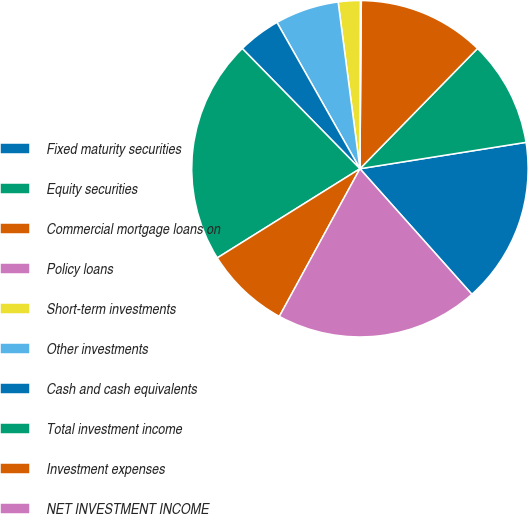Convert chart to OTSL. <chart><loc_0><loc_0><loc_500><loc_500><pie_chart><fcel>Fixed maturity securities<fcel>Equity securities<fcel>Commercial mortgage loans on<fcel>Policy loans<fcel>Short-term investments<fcel>Other investments<fcel>Cash and cash equivalents<fcel>Total investment income<fcel>Investment expenses<fcel>NET INVESTMENT INCOME<nl><fcel>15.92%<fcel>10.17%<fcel>12.19%<fcel>0.09%<fcel>2.11%<fcel>6.14%<fcel>4.12%<fcel>21.56%<fcel>8.16%<fcel>19.54%<nl></chart> 